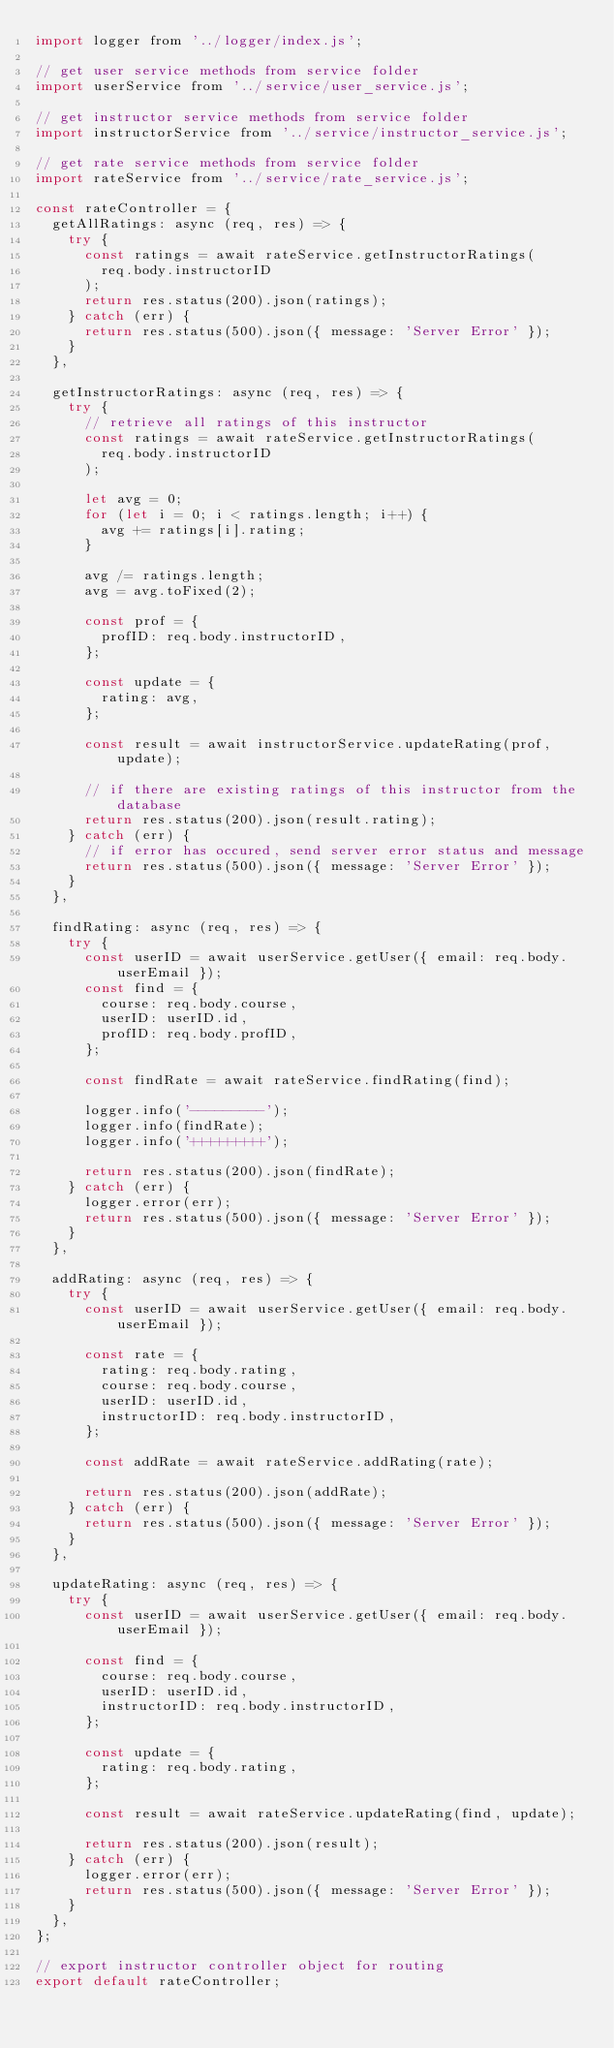<code> <loc_0><loc_0><loc_500><loc_500><_JavaScript_>import logger from '../logger/index.js';

// get user service methods from service folder
import userService from '../service/user_service.js';

// get instructor service methods from service folder
import instructorService from '../service/instructor_service.js';

// get rate service methods from service folder
import rateService from '../service/rate_service.js';

const rateController = {
  getAllRatings: async (req, res) => {
    try {
      const ratings = await rateService.getInstructorRatings(
        req.body.instructorID
      );
      return res.status(200).json(ratings);
    } catch (err) {
      return res.status(500).json({ message: 'Server Error' });
    }
  },

  getInstructorRatings: async (req, res) => {
    try {
      // retrieve all ratings of this instructor
      const ratings = await rateService.getInstructorRatings(
        req.body.instructorID
      );

      let avg = 0;
      for (let i = 0; i < ratings.length; i++) {
        avg += ratings[i].rating;
      }

      avg /= ratings.length;
      avg = avg.toFixed(2);

      const prof = {
        profID: req.body.instructorID,
      };

      const update = {
        rating: avg,
      };

      const result = await instructorService.updateRating(prof, update);

      // if there are existing ratings of this instructor from the database
      return res.status(200).json(result.rating);
    } catch (err) {
      // if error has occured, send server error status and message
      return res.status(500).json({ message: 'Server Error' });
    }
  },

  findRating: async (req, res) => {
    try {
      const userID = await userService.getUser({ email: req.body.userEmail });
      const find = {
        course: req.body.course,
        userID: userID.id,
        profID: req.body.profID,
      };

      const findRate = await rateService.findRating(find);

      logger.info('---------');
      logger.info(findRate);
      logger.info('+++++++++');

      return res.status(200).json(findRate);
    } catch (err) {
      logger.error(err);
      return res.status(500).json({ message: 'Server Error' });
    }
  },

  addRating: async (req, res) => {
    try {
      const userID = await userService.getUser({ email: req.body.userEmail });

      const rate = {
        rating: req.body.rating,
        course: req.body.course,
        userID: userID.id,
        instructorID: req.body.instructorID,
      };

      const addRate = await rateService.addRating(rate);

      return res.status(200).json(addRate);
    } catch (err) {
      return res.status(500).json({ message: 'Server Error' });
    }
  },

  updateRating: async (req, res) => {
    try {
      const userID = await userService.getUser({ email: req.body.userEmail });

      const find = {
        course: req.body.course,
        userID: userID.id,
        instructorID: req.body.instructorID,
      };

      const update = {
        rating: req.body.rating,
      };

      const result = await rateService.updateRating(find, update);

      return res.status(200).json(result);
    } catch (err) {
      logger.error(err);
      return res.status(500).json({ message: 'Server Error' });
    }
  },
};

// export instructor controller object for routing
export default rateController;
</code> 